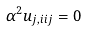<formula> <loc_0><loc_0><loc_500><loc_500>\alpha ^ { 2 } u _ { j , i i j } = 0</formula> 